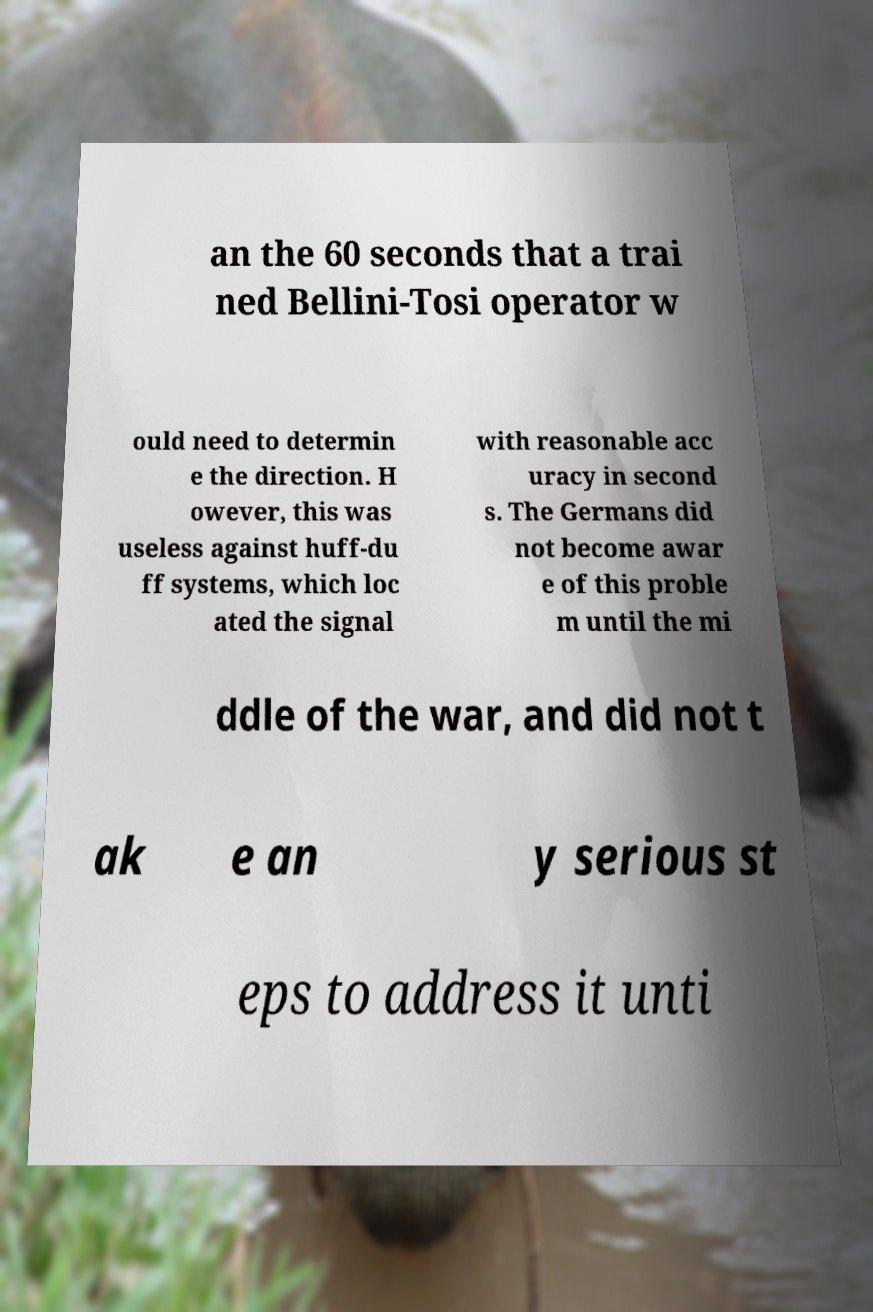What messages or text are displayed in this image? I need them in a readable, typed format. an the 60 seconds that a trai ned Bellini-Tosi operator w ould need to determin e the direction. H owever, this was useless against huff-du ff systems, which loc ated the signal with reasonable acc uracy in second s. The Germans did not become awar e of this proble m until the mi ddle of the war, and did not t ak e an y serious st eps to address it unti 